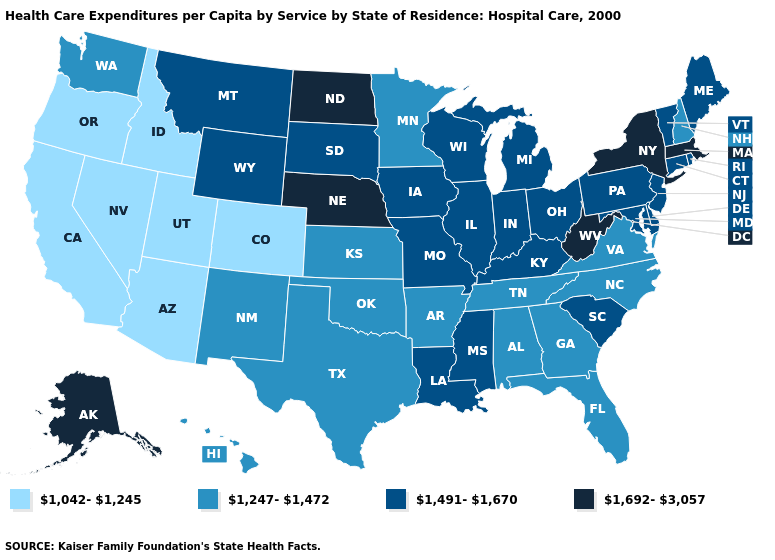Which states have the highest value in the USA?
Write a very short answer. Alaska, Massachusetts, Nebraska, New York, North Dakota, West Virginia. Which states hav the highest value in the West?
Concise answer only. Alaska. What is the value of New Mexico?
Concise answer only. 1,247-1,472. Name the states that have a value in the range 1,692-3,057?
Concise answer only. Alaska, Massachusetts, Nebraska, New York, North Dakota, West Virginia. Does California have the highest value in the West?
Quick response, please. No. Which states have the highest value in the USA?
Concise answer only. Alaska, Massachusetts, Nebraska, New York, North Dakota, West Virginia. What is the value of Nevada?
Write a very short answer. 1,042-1,245. What is the lowest value in states that border New Hampshire?
Quick response, please. 1,491-1,670. Name the states that have a value in the range 1,491-1,670?
Write a very short answer. Connecticut, Delaware, Illinois, Indiana, Iowa, Kentucky, Louisiana, Maine, Maryland, Michigan, Mississippi, Missouri, Montana, New Jersey, Ohio, Pennsylvania, Rhode Island, South Carolina, South Dakota, Vermont, Wisconsin, Wyoming. Does the first symbol in the legend represent the smallest category?
Answer briefly. Yes. Does Alaska have the highest value in the West?
Keep it brief. Yes. What is the highest value in the USA?
Write a very short answer. 1,692-3,057. Which states have the lowest value in the USA?
Give a very brief answer. Arizona, California, Colorado, Idaho, Nevada, Oregon, Utah. Name the states that have a value in the range 1,247-1,472?
Short answer required. Alabama, Arkansas, Florida, Georgia, Hawaii, Kansas, Minnesota, New Hampshire, New Mexico, North Carolina, Oklahoma, Tennessee, Texas, Virginia, Washington. What is the value of Hawaii?
Write a very short answer. 1,247-1,472. 